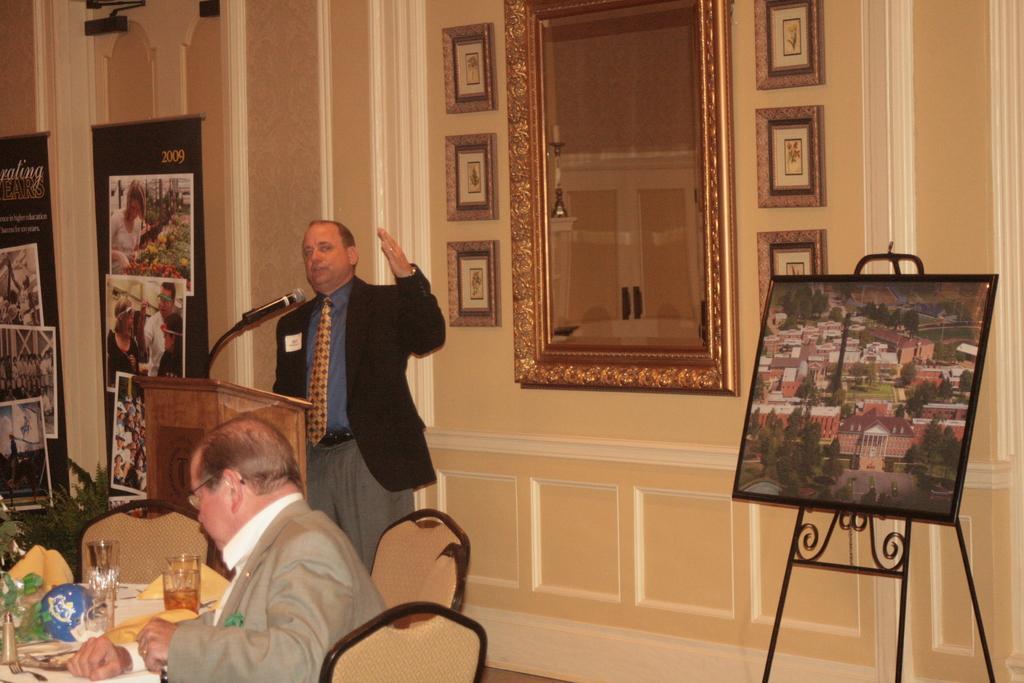Could you give a brief overview of what you see in this image? On the background we can see window, wall and few frames over a wall. These are flexis. Here we can see one man standing in front of a podium and talking. This is a mic. Here we can see one picture. We can see one man sitting on chair in front of a table and on the table we can see drinking glasses, flower vase. 